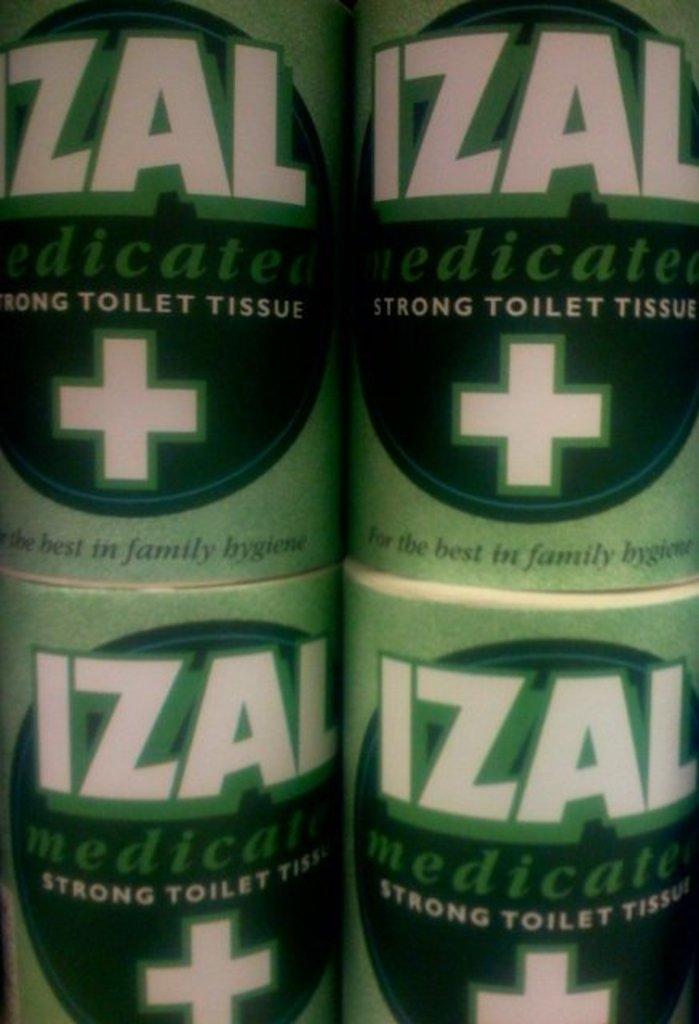What type of hygiene product is this?
Offer a very short reply. Toilet tissue. What is the brand of tp?
Make the answer very short. Izal. 